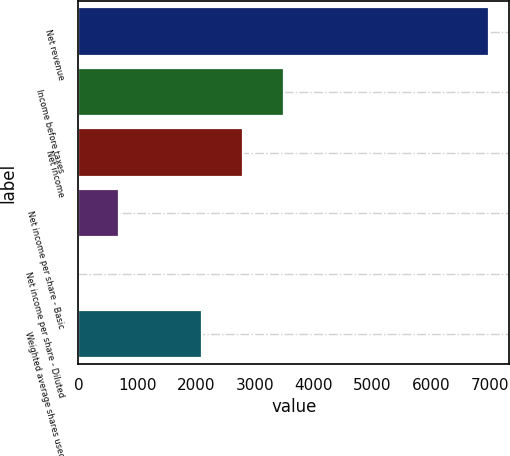Convert chart to OTSL. <chart><loc_0><loc_0><loc_500><loc_500><bar_chart><fcel>Net revenue<fcel>Income before taxes<fcel>Net income<fcel>Net income per share - Basic<fcel>Net income per share - Diluted<fcel>Weighted average shares used<nl><fcel>6981<fcel>3491.24<fcel>2793.29<fcel>699.44<fcel>1.49<fcel>2095.34<nl></chart> 